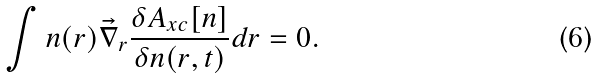<formula> <loc_0><loc_0><loc_500><loc_500>\int n ( { r } ) \vec { \nabla } _ { r } \frac { \delta A _ { x c } [ n ] } { \delta n ( { r } , t ) } d { r } = 0 .</formula> 